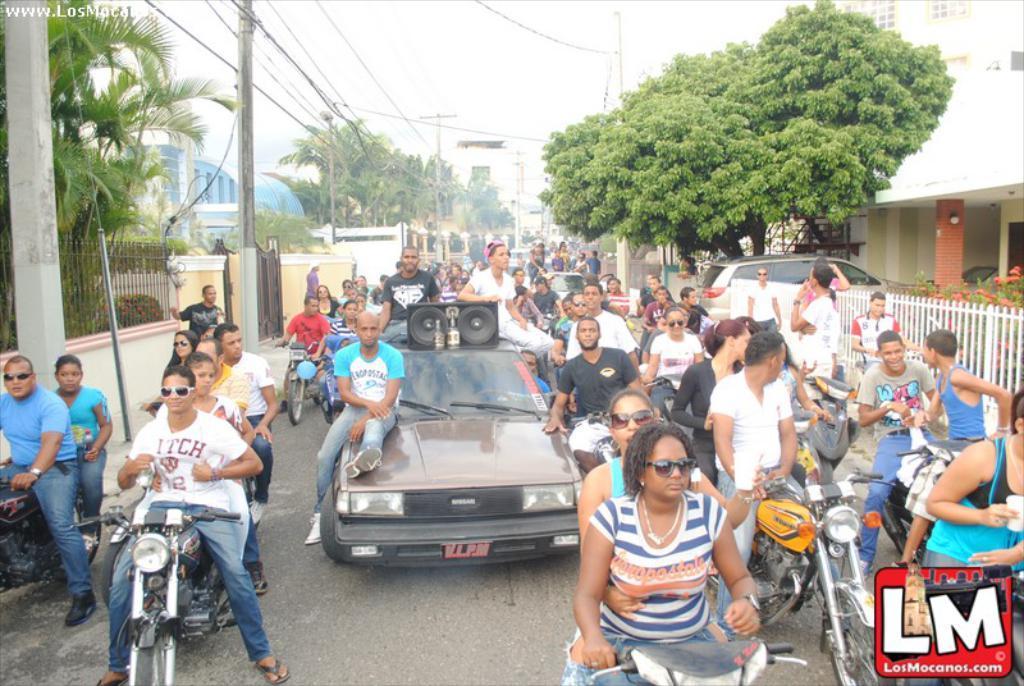Please provide a concise description of this image. In this image, there is a crowd wearing colorful clothes. There are some person at the bottom of this picture riding bikes. There are three persons sitting on the car which is in the center of this image. There are some trees at the top of this image. There is a building in the top right of the image. 